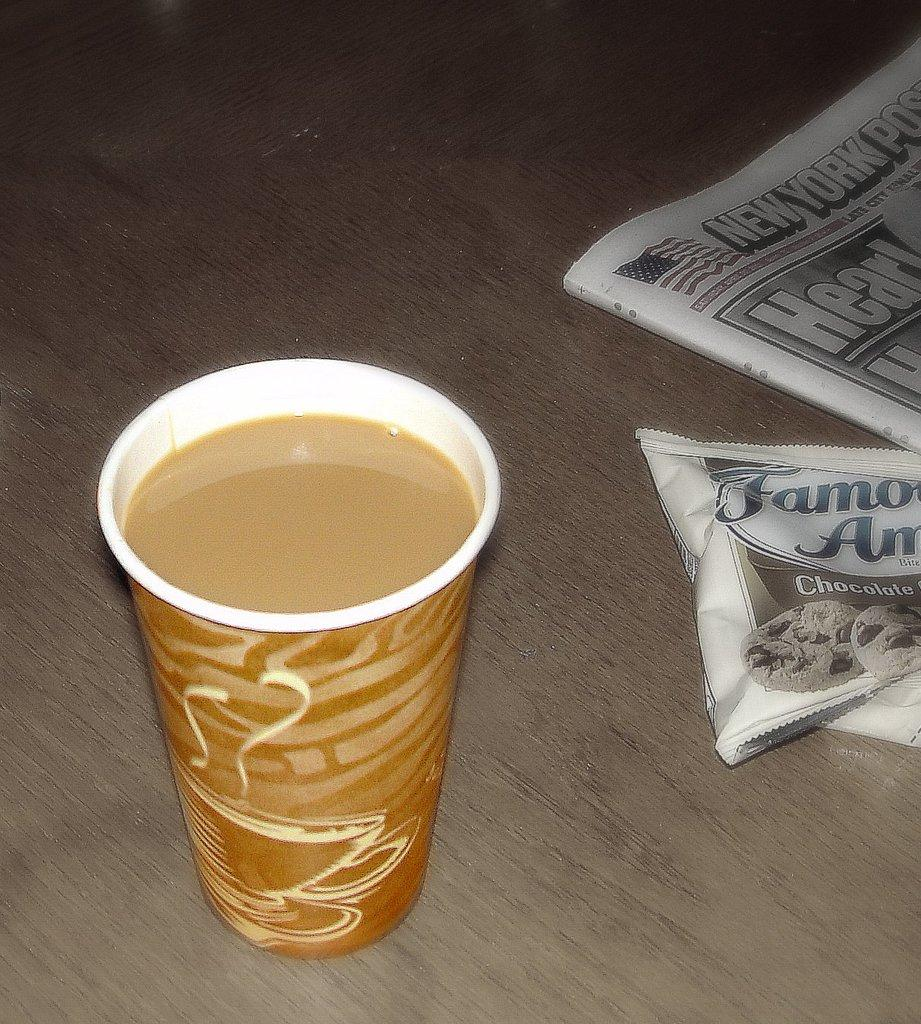What is in the glass that is visible in the image? There is a drink in the glass that is visible in the image. What is the glass placed on in the image? The glass is on a wooden surface in the image. What type of reading material is present in the image? There is a newspaper in the image. What else can be seen in the image besides the glass and newspaper? There is a packet in the image. What type of steel object is visible in the image? There is no steel object present in the image. How does the newspaper slip off the wooden surface in the image? The newspaper does not slip off the wooden surface in the image; it is stationary. What type of agreement is being made in the image? There is no agreement being made in the image; it only features a glass with a drink, a wooden surface, a newspaper, and a packet. 